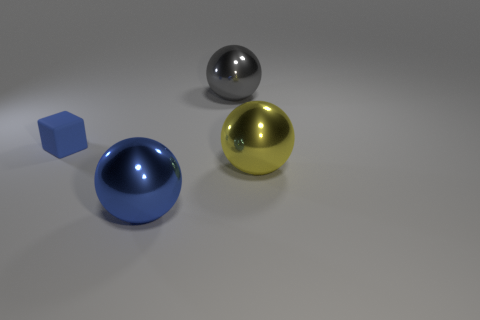There is a blue object that is made of the same material as the yellow sphere; what shape is it?
Your response must be concise. Sphere. The large yellow metal object is what shape?
Keep it short and to the point. Sphere. The thing that is behind the large yellow sphere and left of the big gray metallic object is what color?
Your answer should be very brief. Blue. What is the shape of the yellow object that is the same size as the blue shiny ball?
Make the answer very short. Sphere. Are there any big gray matte things of the same shape as the small thing?
Keep it short and to the point. No. Does the small blue cube have the same material as the ball right of the gray metal thing?
Your answer should be very brief. No. What color is the metallic sphere that is on the right side of the large sphere behind the large ball right of the large gray shiny object?
Your answer should be compact. Yellow. There is a gray thing that is the same size as the blue sphere; what material is it?
Offer a terse response. Metal. How many blue blocks are the same material as the tiny blue thing?
Offer a terse response. 0. Do the metallic thing behind the blue matte block and the thing in front of the big yellow thing have the same size?
Provide a short and direct response. Yes. 